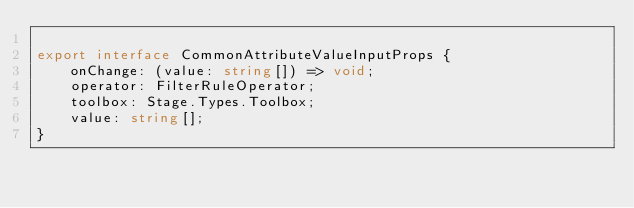<code> <loc_0><loc_0><loc_500><loc_500><_TypeScript_>
export interface CommonAttributeValueInputProps {
    onChange: (value: string[]) => void;
    operator: FilterRuleOperator;
    toolbox: Stage.Types.Toolbox;
    value: string[];
}
</code> 